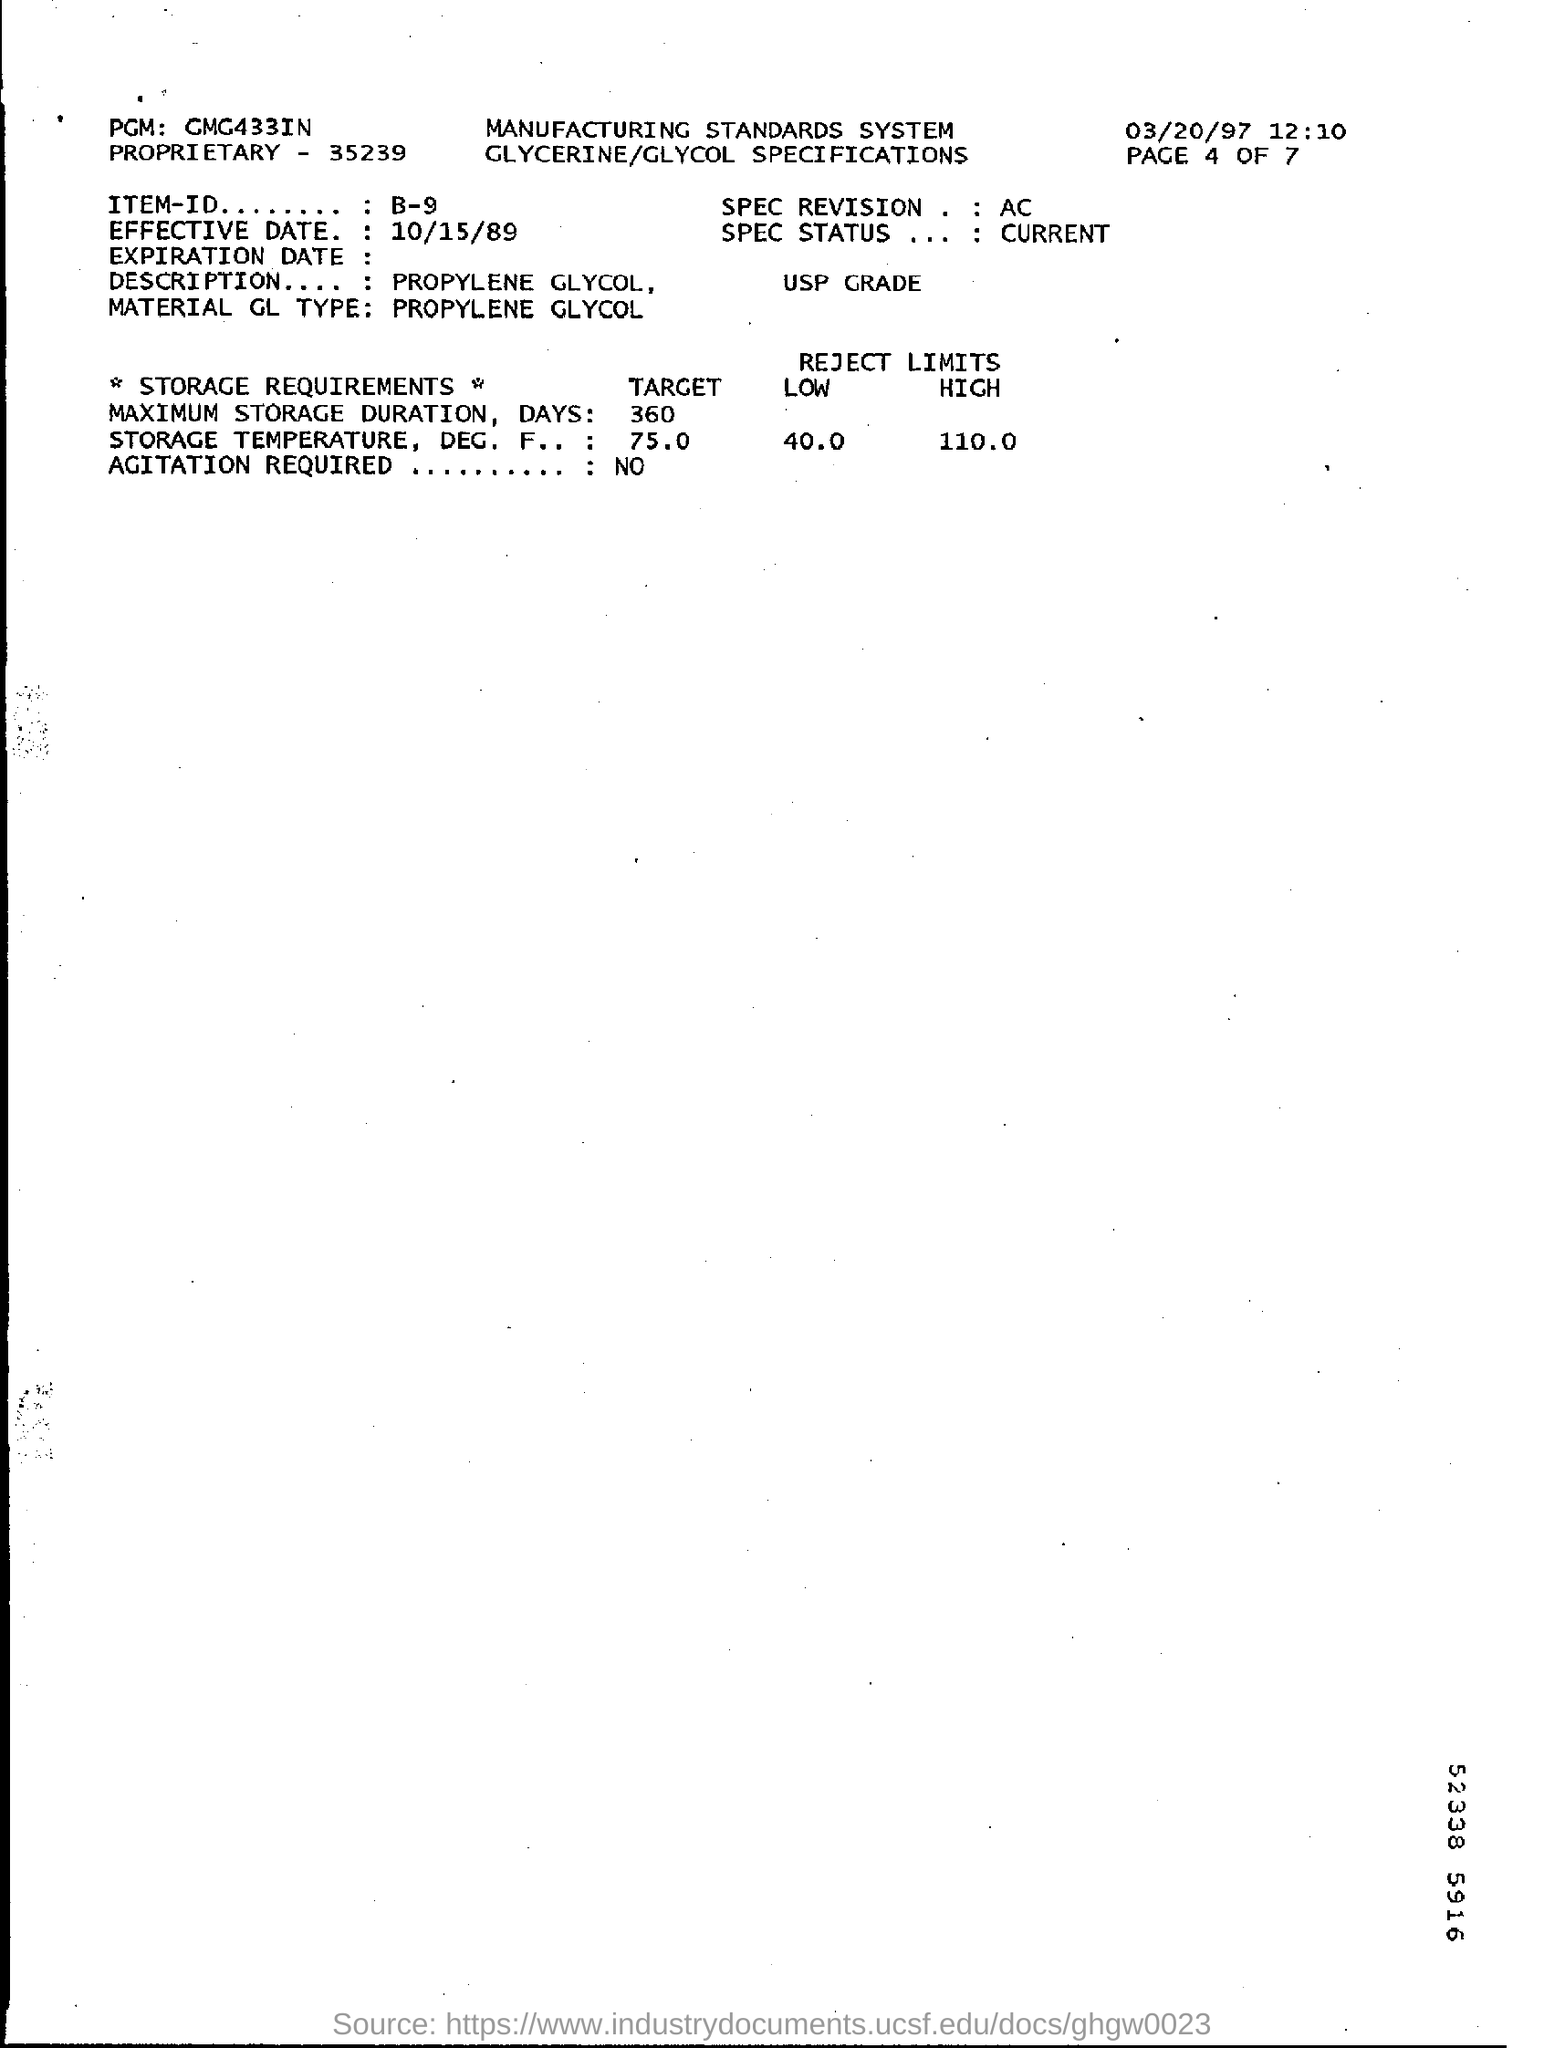What is the ITEM-ID given in the document?
Provide a short and direct response. B-9. What is the Material GL Type?
Your answer should be compact. PROPYLENE GLYCOL. What is the maximum storage duration days?
Provide a succinct answer. 360. What is the Effective Date mentioned in this document?
Your answer should be compact. 10/15/89. 